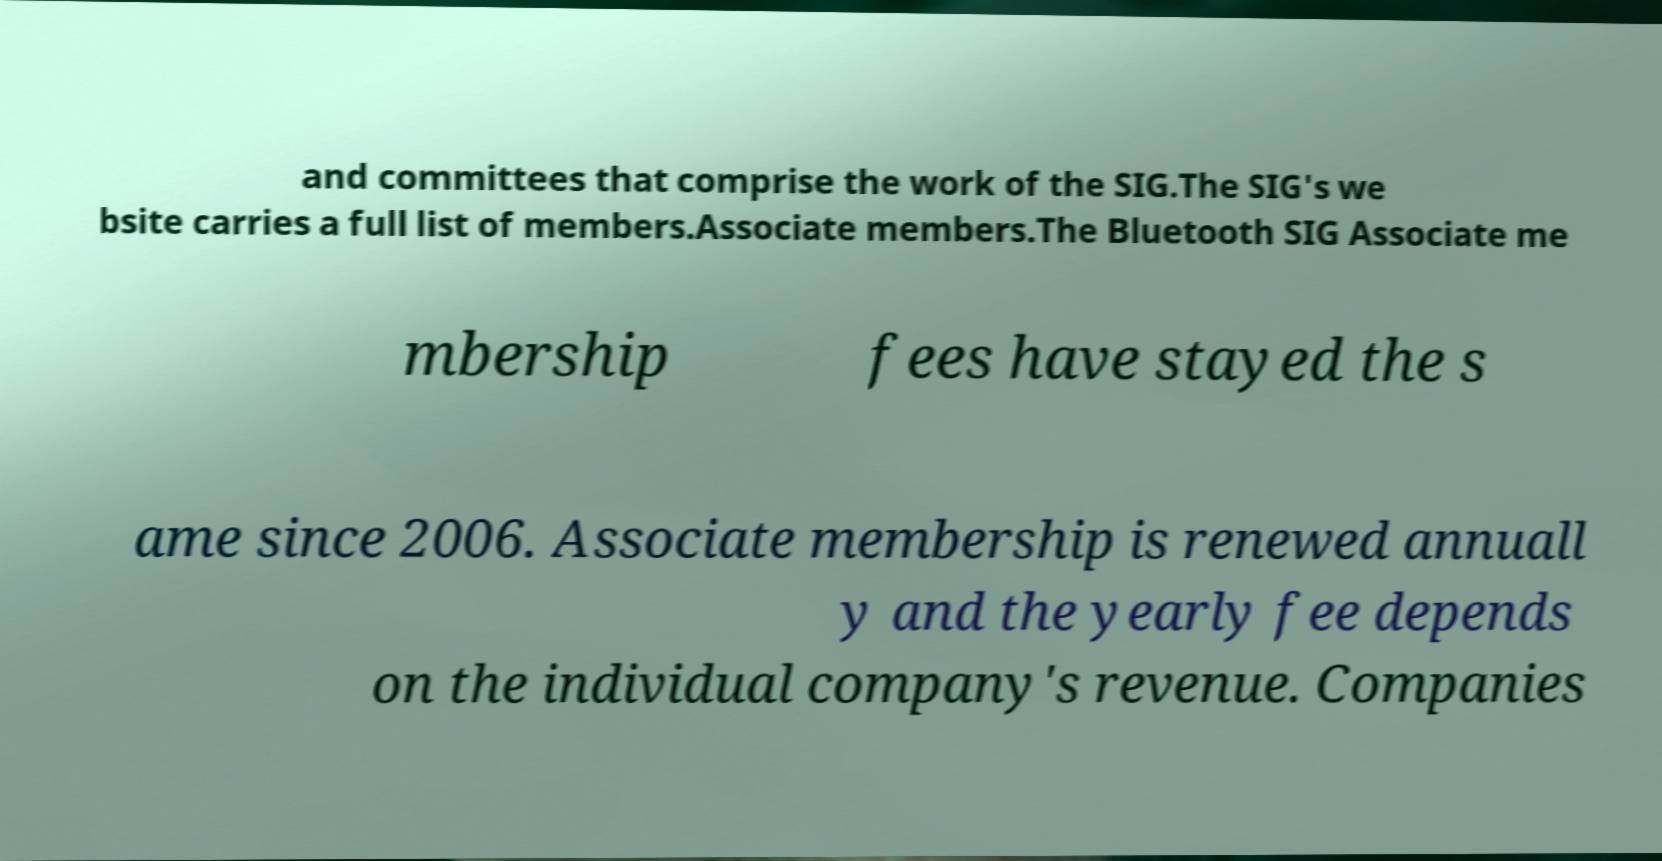Please read and relay the text visible in this image. What does it say? and committees that comprise the work of the SIG.The SIG's we bsite carries a full list of members.Associate members.The Bluetooth SIG Associate me mbership fees have stayed the s ame since 2006. Associate membership is renewed annuall y and the yearly fee depends on the individual company's revenue. Companies 